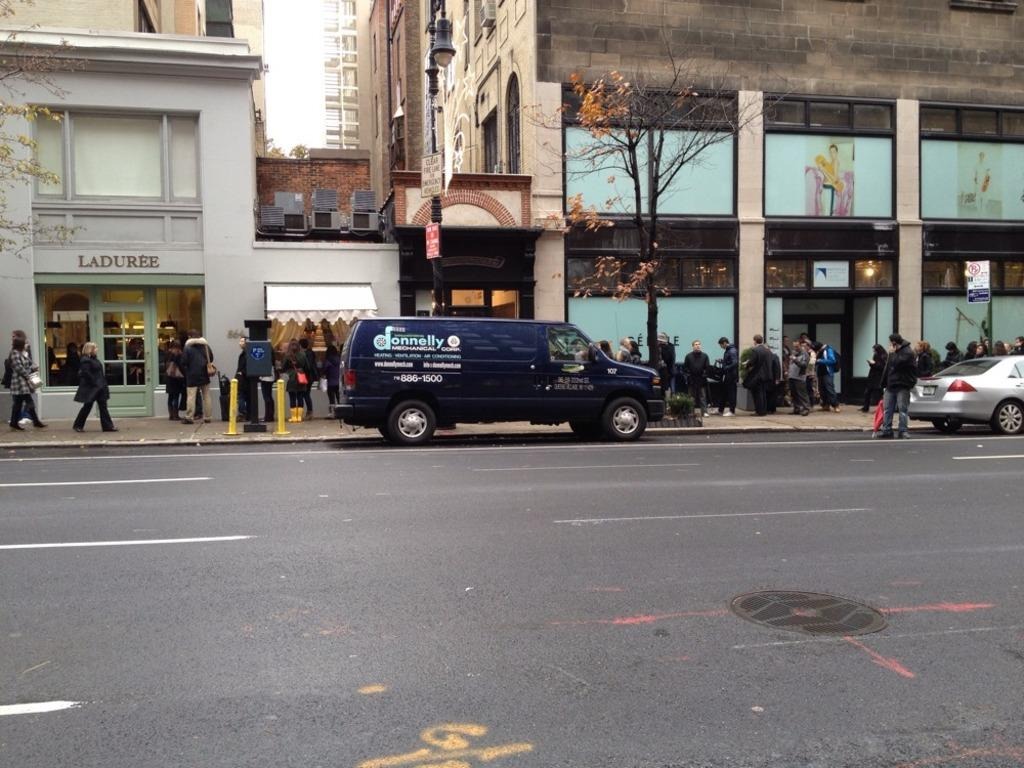Provide a one-sentence caption for the provided image. A street with the store Laduree and a large amount of pedestrians. 